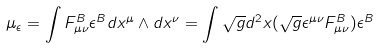Convert formula to latex. <formula><loc_0><loc_0><loc_500><loc_500>\mu _ { \epsilon } = \int F _ { \mu \nu } ^ { B } \epsilon ^ { B } d x ^ { \mu } \wedge d x ^ { \nu } = \int \sqrt { g } d ^ { 2 } x ( \sqrt { g } \epsilon ^ { \mu \nu } F _ { \mu \nu } ^ { B } ) \epsilon ^ { B }</formula> 